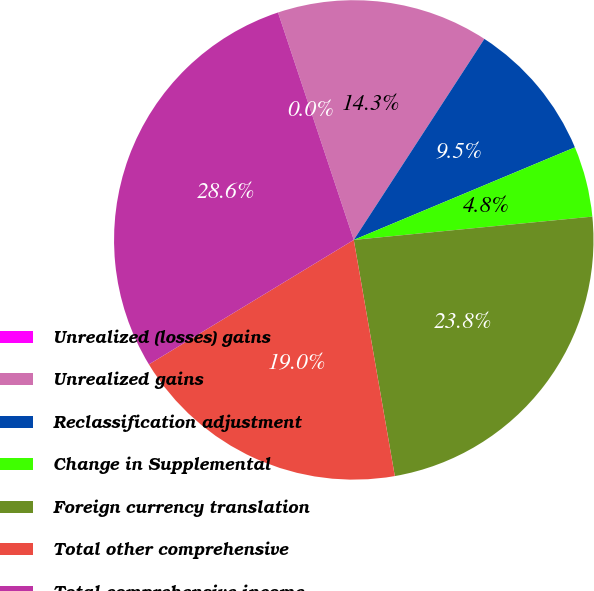<chart> <loc_0><loc_0><loc_500><loc_500><pie_chart><fcel>Unrealized (losses) gains<fcel>Unrealized gains<fcel>Reclassification adjustment<fcel>Change in Supplemental<fcel>Foreign currency translation<fcel>Total other comprehensive<fcel>Total comprehensive income<nl><fcel>0.0%<fcel>14.29%<fcel>9.52%<fcel>4.76%<fcel>23.81%<fcel>19.05%<fcel>28.57%<nl></chart> 